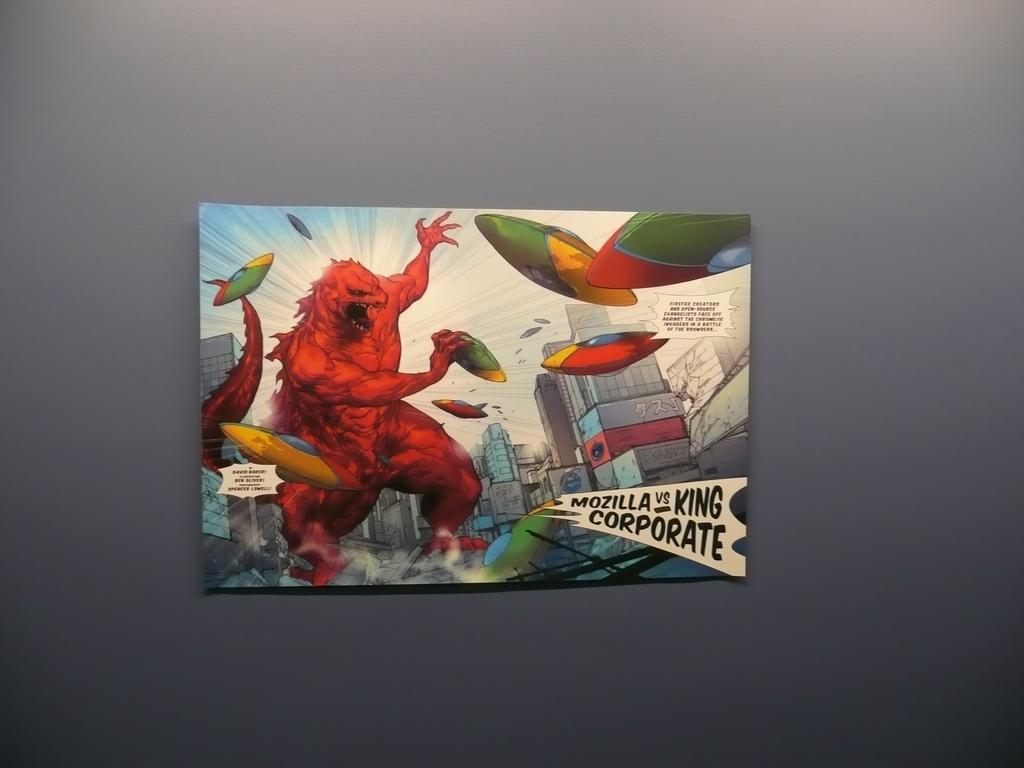Who is fighting in the art piece?
Provide a succinct answer. Mozilla vs king corporate. Whsat is the last word on the bottom right?
Offer a very short reply. Corporate. 